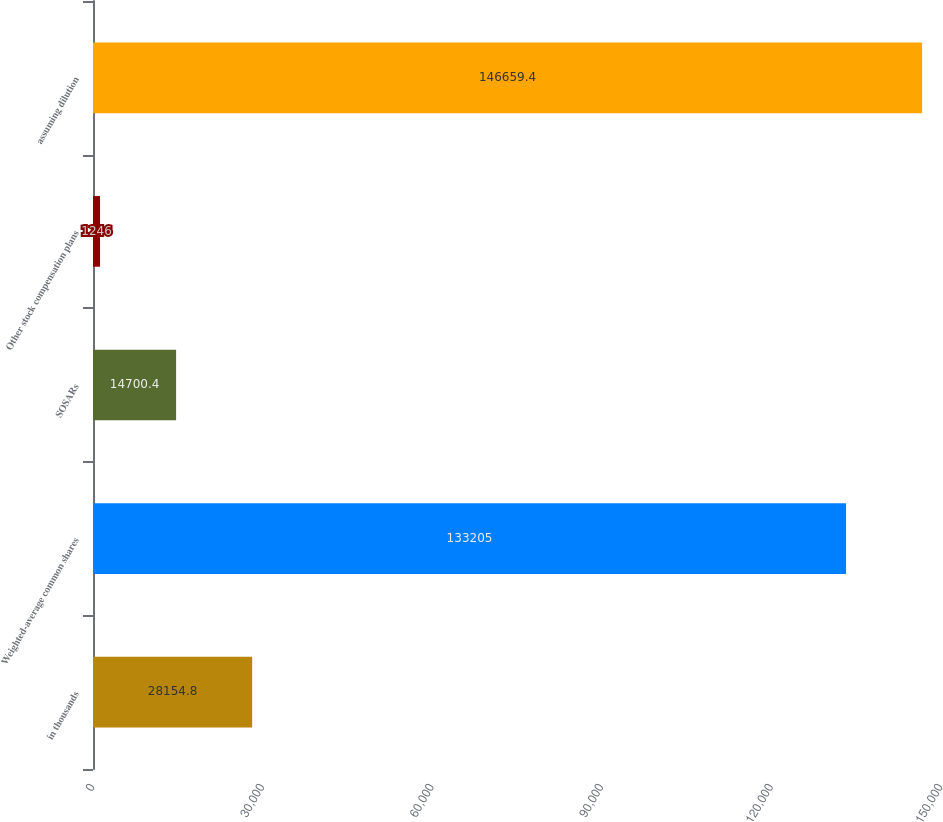<chart> <loc_0><loc_0><loc_500><loc_500><bar_chart><fcel>in thousands<fcel>Weighted-average common shares<fcel>SOSARs<fcel>Other stock compensation plans<fcel>assuming dilution<nl><fcel>28154.8<fcel>133205<fcel>14700.4<fcel>1246<fcel>146659<nl></chart> 